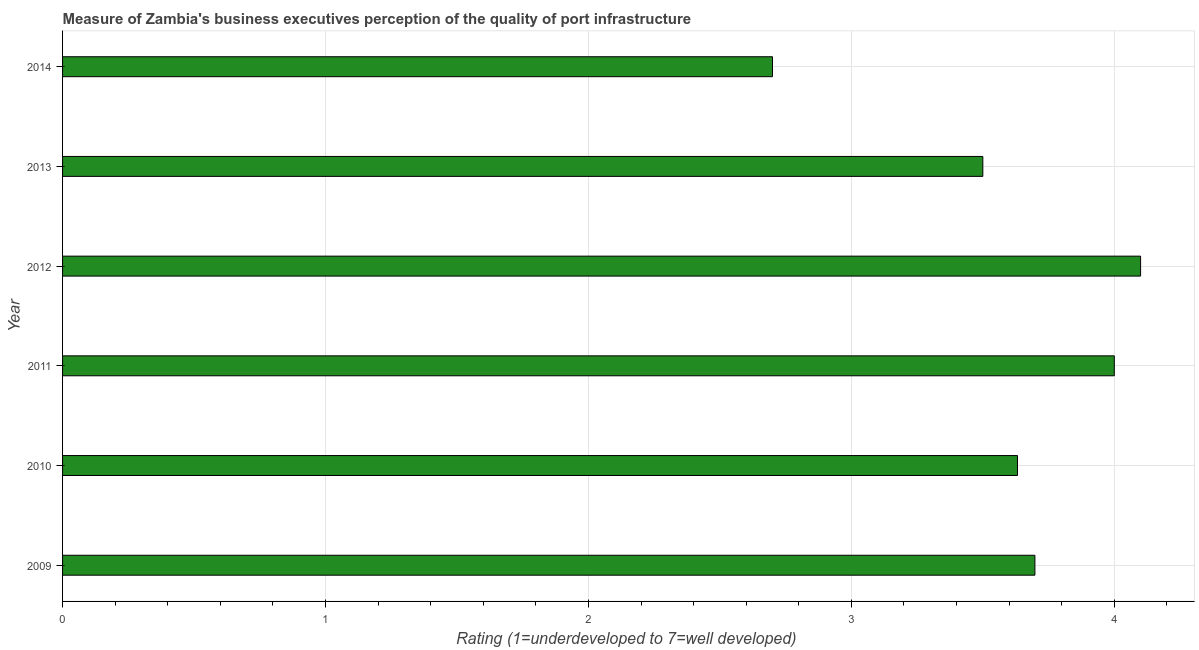What is the title of the graph?
Your answer should be compact. Measure of Zambia's business executives perception of the quality of port infrastructure. What is the label or title of the X-axis?
Offer a terse response. Rating (1=underdeveloped to 7=well developed) . What is the label or title of the Y-axis?
Your response must be concise. Year. What is the rating measuring quality of port infrastructure in 2013?
Keep it short and to the point. 3.5. In which year was the rating measuring quality of port infrastructure maximum?
Make the answer very short. 2012. What is the sum of the rating measuring quality of port infrastructure?
Your answer should be very brief. 21.63. What is the difference between the rating measuring quality of port infrastructure in 2010 and 2012?
Your answer should be compact. -0.47. What is the average rating measuring quality of port infrastructure per year?
Your response must be concise. 3.6. What is the median rating measuring quality of port infrastructure?
Provide a succinct answer. 3.66. In how many years, is the rating measuring quality of port infrastructure greater than 2.4 ?
Your response must be concise. 6. Do a majority of the years between 2014 and 2010 (inclusive) have rating measuring quality of port infrastructure greater than 2.4 ?
Your answer should be compact. Yes. What is the difference between the highest and the lowest rating measuring quality of port infrastructure?
Your answer should be very brief. 1.4. Are all the bars in the graph horizontal?
Make the answer very short. Yes. How many years are there in the graph?
Offer a terse response. 6. What is the difference between two consecutive major ticks on the X-axis?
Keep it short and to the point. 1. What is the Rating (1=underdeveloped to 7=well developed)  of 2009?
Offer a terse response. 3.7. What is the Rating (1=underdeveloped to 7=well developed)  of 2010?
Your answer should be compact. 3.63. What is the Rating (1=underdeveloped to 7=well developed)  in 2011?
Your answer should be compact. 4. What is the Rating (1=underdeveloped to 7=well developed)  in 2014?
Offer a very short reply. 2.7. What is the difference between the Rating (1=underdeveloped to 7=well developed)  in 2009 and 2010?
Provide a succinct answer. 0.07. What is the difference between the Rating (1=underdeveloped to 7=well developed)  in 2009 and 2011?
Your answer should be very brief. -0.3. What is the difference between the Rating (1=underdeveloped to 7=well developed)  in 2009 and 2012?
Offer a very short reply. -0.4. What is the difference between the Rating (1=underdeveloped to 7=well developed)  in 2009 and 2013?
Provide a short and direct response. 0.2. What is the difference between the Rating (1=underdeveloped to 7=well developed)  in 2009 and 2014?
Offer a terse response. 1. What is the difference between the Rating (1=underdeveloped to 7=well developed)  in 2010 and 2011?
Keep it short and to the point. -0.37. What is the difference between the Rating (1=underdeveloped to 7=well developed)  in 2010 and 2012?
Make the answer very short. -0.47. What is the difference between the Rating (1=underdeveloped to 7=well developed)  in 2010 and 2013?
Your response must be concise. 0.13. What is the difference between the Rating (1=underdeveloped to 7=well developed)  in 2010 and 2014?
Offer a very short reply. 0.93. What is the difference between the Rating (1=underdeveloped to 7=well developed)  in 2011 and 2012?
Make the answer very short. -0.1. What is the difference between the Rating (1=underdeveloped to 7=well developed)  in 2011 and 2013?
Provide a succinct answer. 0.5. What is the difference between the Rating (1=underdeveloped to 7=well developed)  in 2011 and 2014?
Keep it short and to the point. 1.3. What is the difference between the Rating (1=underdeveloped to 7=well developed)  in 2012 and 2014?
Your answer should be compact. 1.4. What is the difference between the Rating (1=underdeveloped to 7=well developed)  in 2013 and 2014?
Your answer should be very brief. 0.8. What is the ratio of the Rating (1=underdeveloped to 7=well developed)  in 2009 to that in 2011?
Offer a terse response. 0.93. What is the ratio of the Rating (1=underdeveloped to 7=well developed)  in 2009 to that in 2012?
Your answer should be very brief. 0.9. What is the ratio of the Rating (1=underdeveloped to 7=well developed)  in 2009 to that in 2013?
Your answer should be compact. 1.06. What is the ratio of the Rating (1=underdeveloped to 7=well developed)  in 2009 to that in 2014?
Provide a short and direct response. 1.37. What is the ratio of the Rating (1=underdeveloped to 7=well developed)  in 2010 to that in 2011?
Make the answer very short. 0.91. What is the ratio of the Rating (1=underdeveloped to 7=well developed)  in 2010 to that in 2012?
Offer a very short reply. 0.89. What is the ratio of the Rating (1=underdeveloped to 7=well developed)  in 2010 to that in 2013?
Keep it short and to the point. 1.04. What is the ratio of the Rating (1=underdeveloped to 7=well developed)  in 2010 to that in 2014?
Offer a terse response. 1.34. What is the ratio of the Rating (1=underdeveloped to 7=well developed)  in 2011 to that in 2012?
Provide a succinct answer. 0.98. What is the ratio of the Rating (1=underdeveloped to 7=well developed)  in 2011 to that in 2013?
Your answer should be very brief. 1.14. What is the ratio of the Rating (1=underdeveloped to 7=well developed)  in 2011 to that in 2014?
Keep it short and to the point. 1.48. What is the ratio of the Rating (1=underdeveloped to 7=well developed)  in 2012 to that in 2013?
Keep it short and to the point. 1.17. What is the ratio of the Rating (1=underdeveloped to 7=well developed)  in 2012 to that in 2014?
Your answer should be very brief. 1.52. What is the ratio of the Rating (1=underdeveloped to 7=well developed)  in 2013 to that in 2014?
Offer a terse response. 1.3. 